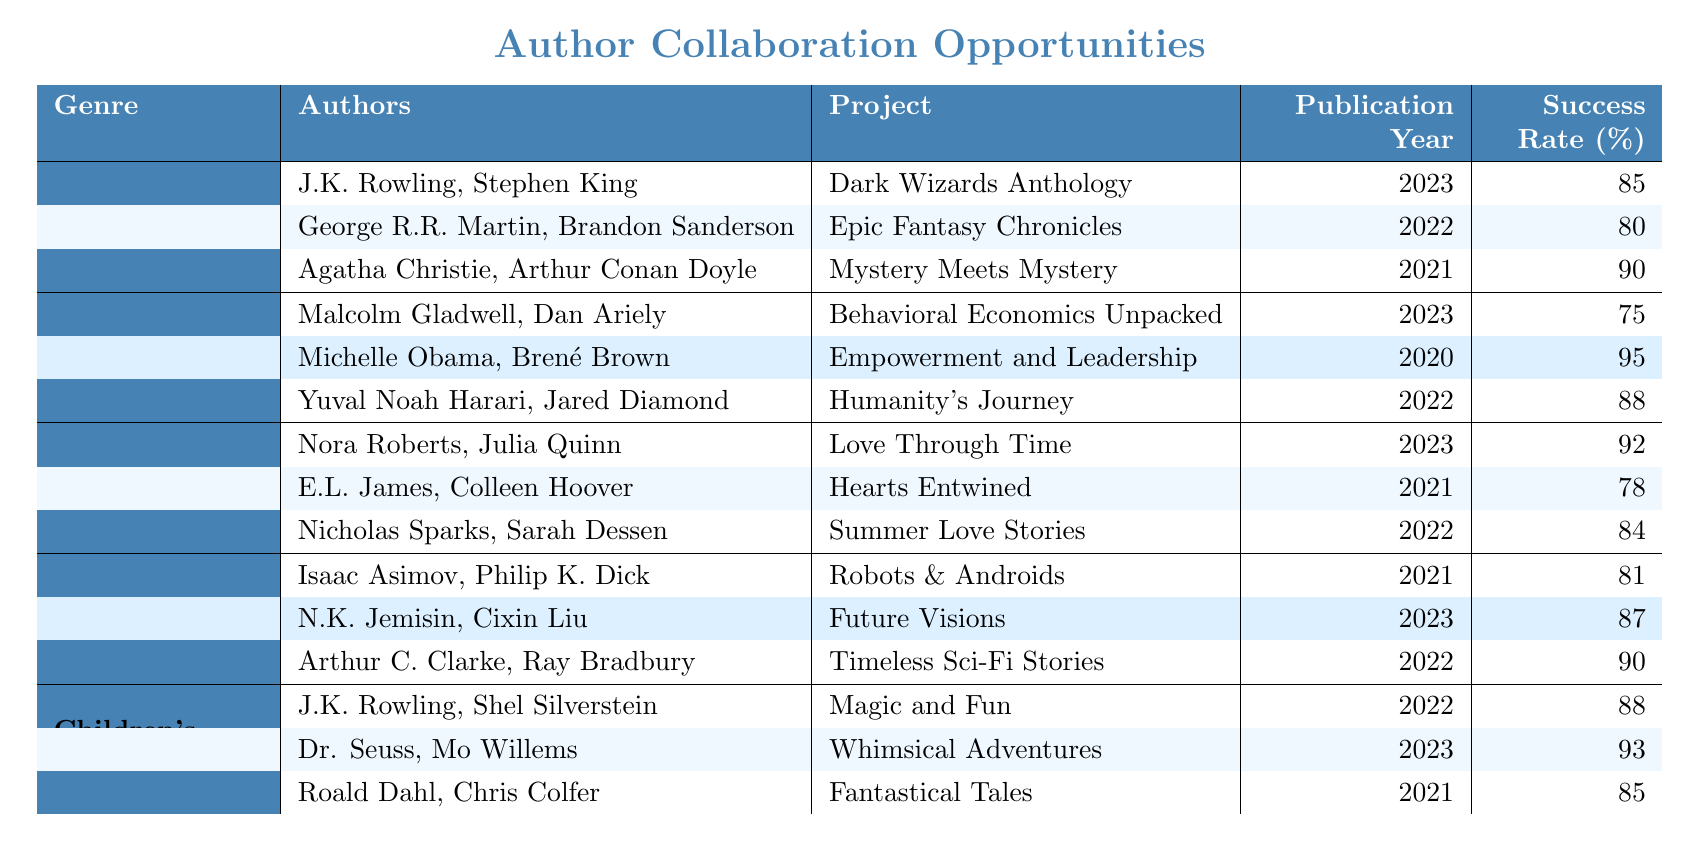What is the highest success rate among collaboration projects in Fiction? The highest success rate in Fiction is found in the collaboration between Agatha Christie and Arthur Conan Doyle for their project "Mystery Meets Mystery," which has a success rate of 90%.
Answer: 90% Which genre has the project with the lowest success rate? In the table, the Non-Fiction genre has the project "Behavioral Economics Unpacked" with a success rate of 75%, which is the lowest among all genres.
Answer: Non-Fiction What are the publication years of the collaboration projects in Romance? The publication years for the Romance collaborations are: "Love Through Time" (2023), "Hearts Entwined" (2021), and "Summer Love Stories" (2022).
Answer: 2023, 2021, 2022 Which two authors collaborated on the project "Whimsical Adventures"? The authors who collaborated on "Whimsical Adventures" are Dr. Seuss and Mo Willems.
Answer: Dr. Seuss, Mo Willems What is the average success rate of collaboration projects in Science Fiction? For Science Fiction, the success rates are 81%, 87%, and 90%. The average is calculated as (81 + 87 + 90) / 3 = 86%.
Answer: 86% Did any collaboration project in Children's Literature achieve a success rate higher than 90%? Yes, the project "Whimsical Adventures" with authors Dr. Seuss and Mo Willems achieved a success rate of 93%, which is higher than 90%.
Answer: Yes How many collaboration projects have a success rate of 85% or higher? The collaboration projects with a success rate of 85% or higher are: "Dark Wizards Anthology," "Mystery Meets Mystery," "Empowerment and Leadership," "Love Through Time," "Future Visions," "Timeless Sci-Fi Stories," "Magic and Fun," and "Whimsical Adventures." Summing them up gives 8 projects.
Answer: 8 What are the authors involved in the "Epic Fantasy Chronicles" project? The authors of "Epic Fantasy Chronicles" are George R.R. Martin and Brandon Sanderson.
Answer: George R.R. Martin, Brandon Sanderson Which genre has the collaboration with the oldest publication year and what is that year? The oldest publication year is 2020, and it belongs to the Non-Fiction genre's project "Empowerment and Leadership."
Answer: 2020 What is the total success rate of all collaboration projects in Fiction? The success rates in Fiction are 85%, 80%, and 90%. Summing these gives 85 + 80 + 90 = 255. Therefore, the total success rate is 255%.
Answer: 255% 